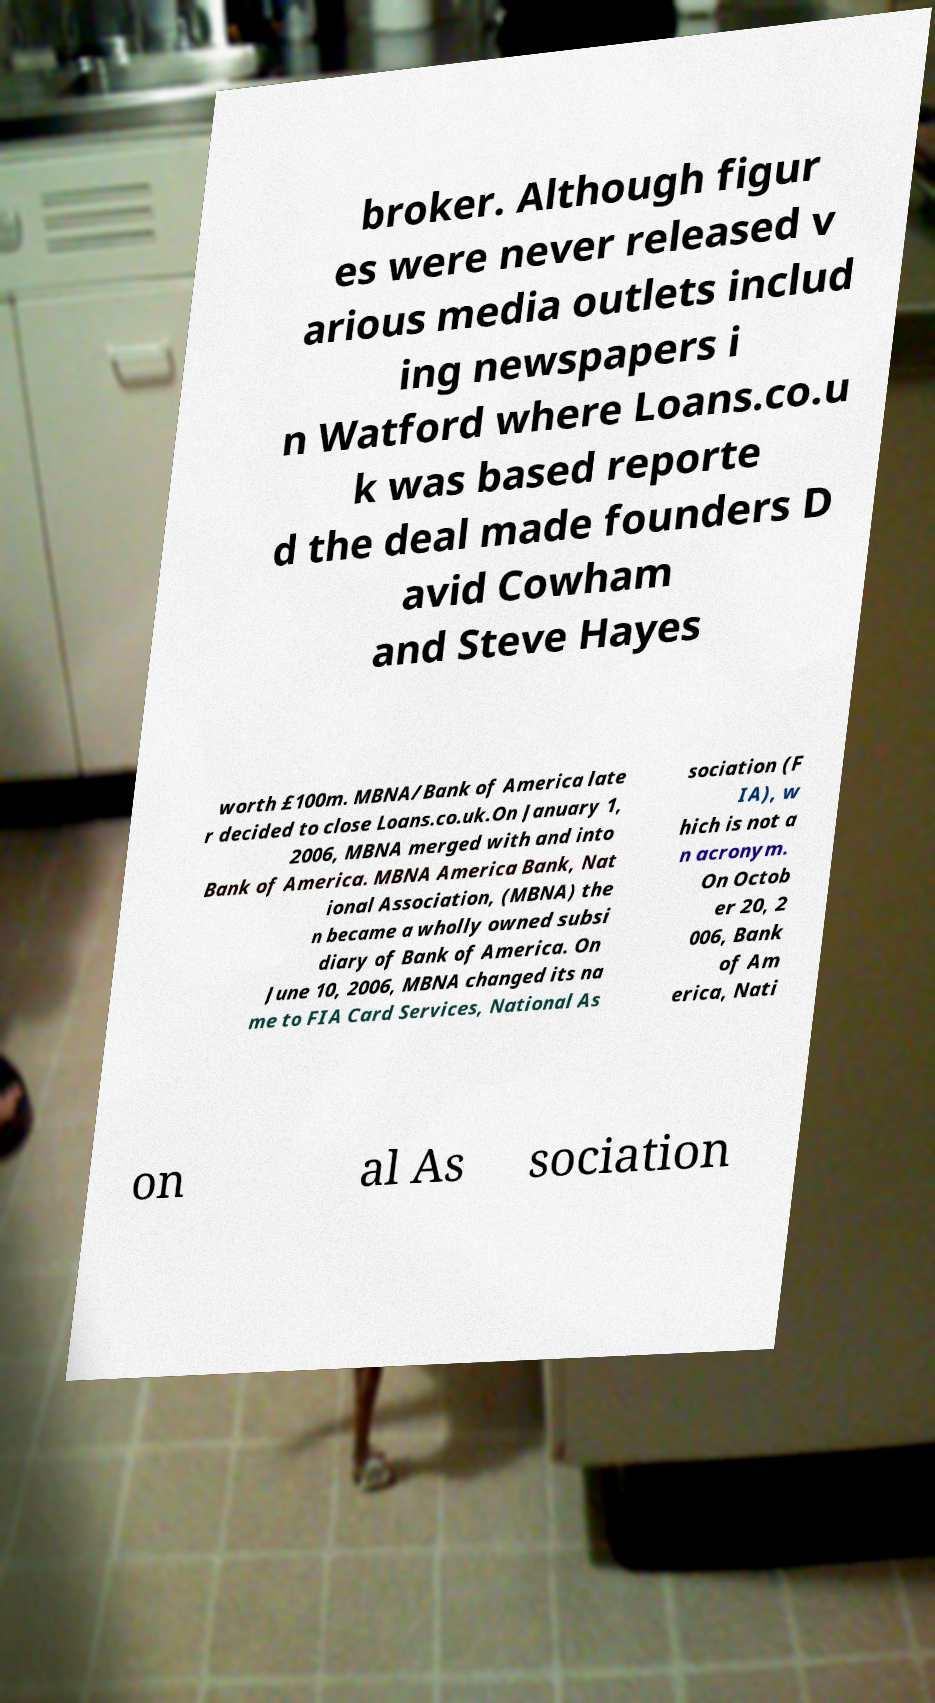Could you assist in decoding the text presented in this image and type it out clearly? broker. Although figur es were never released v arious media outlets includ ing newspapers i n Watford where Loans.co.u k was based reporte d the deal made founders D avid Cowham and Steve Hayes worth £100m. MBNA/Bank of America late r decided to close Loans.co.uk.On January 1, 2006, MBNA merged with and into Bank of America. MBNA America Bank, Nat ional Association, (MBNA) the n became a wholly owned subsi diary of Bank of America. On June 10, 2006, MBNA changed its na me to FIA Card Services, National As sociation (F IA), w hich is not a n acronym. On Octob er 20, 2 006, Bank of Am erica, Nati on al As sociation 